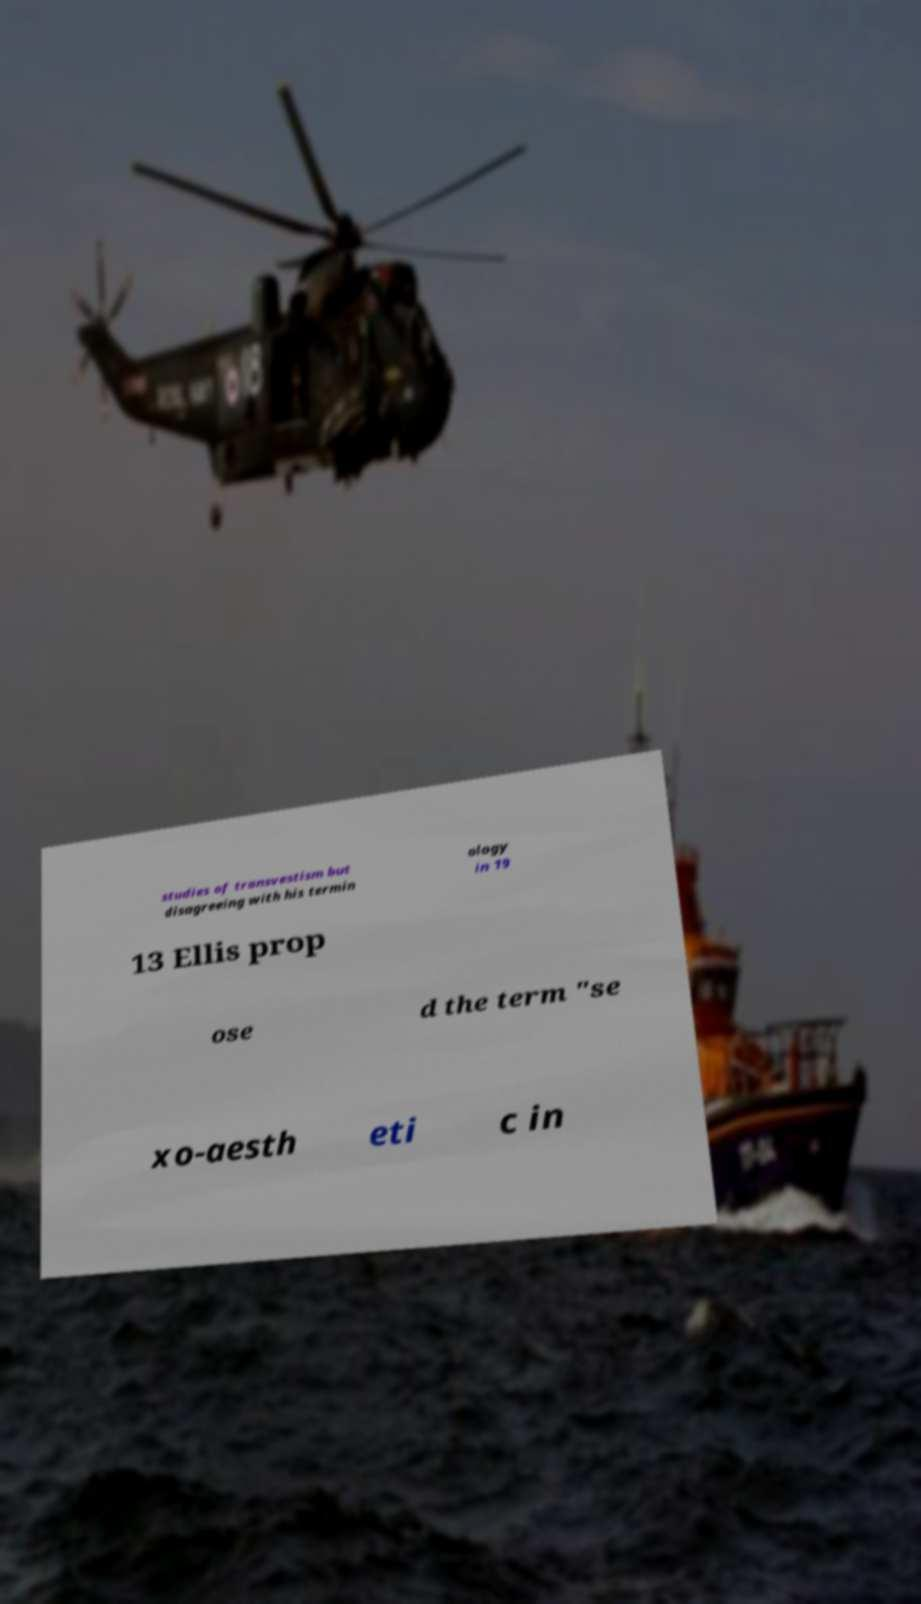What messages or text are displayed in this image? I need them in a readable, typed format. studies of transvestism but disagreeing with his termin ology in 19 13 Ellis prop ose d the term "se xo-aesth eti c in 